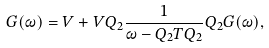<formula> <loc_0><loc_0><loc_500><loc_500>G ( \omega ) = V + V Q _ { 2 } \frac { 1 } { \omega - Q _ { 2 } T Q _ { 2 } } Q _ { 2 } G ( \omega ) ,</formula> 